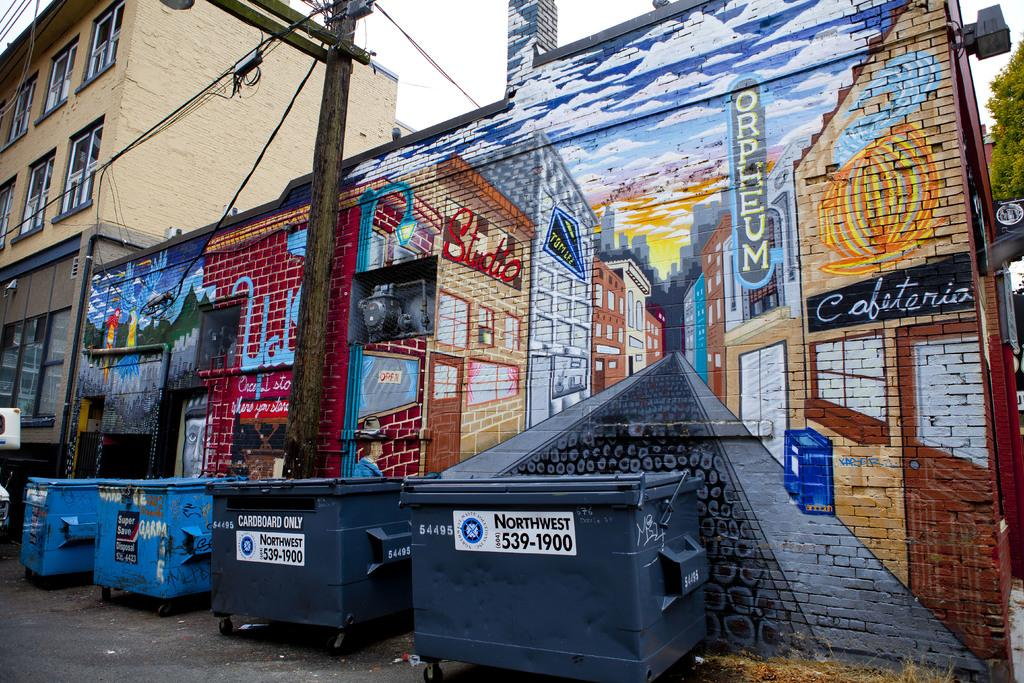<image>
Write a terse but informative summary of the picture. Several dumpsters that say NorthWest are lined up against a painted wall 